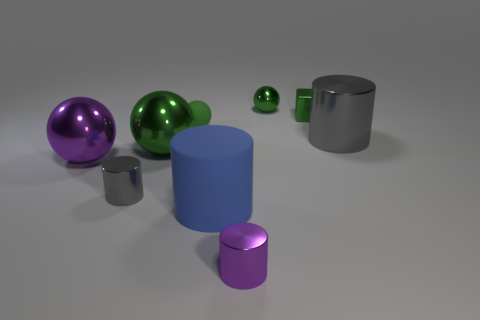Subtract all metal balls. How many balls are left? 1 Add 1 large blue metal spheres. How many objects exist? 10 Subtract all cubes. How many objects are left? 8 Subtract 1 cylinders. How many cylinders are left? 3 Subtract all purple balls. Subtract all red cylinders. How many balls are left? 3 Subtract all yellow cylinders. How many blue blocks are left? 0 Subtract all purple things. Subtract all tiny green matte balls. How many objects are left? 6 Add 9 purple shiny spheres. How many purple shiny spheres are left? 10 Add 7 blue things. How many blue things exist? 8 Subtract all purple spheres. How many spheres are left? 3 